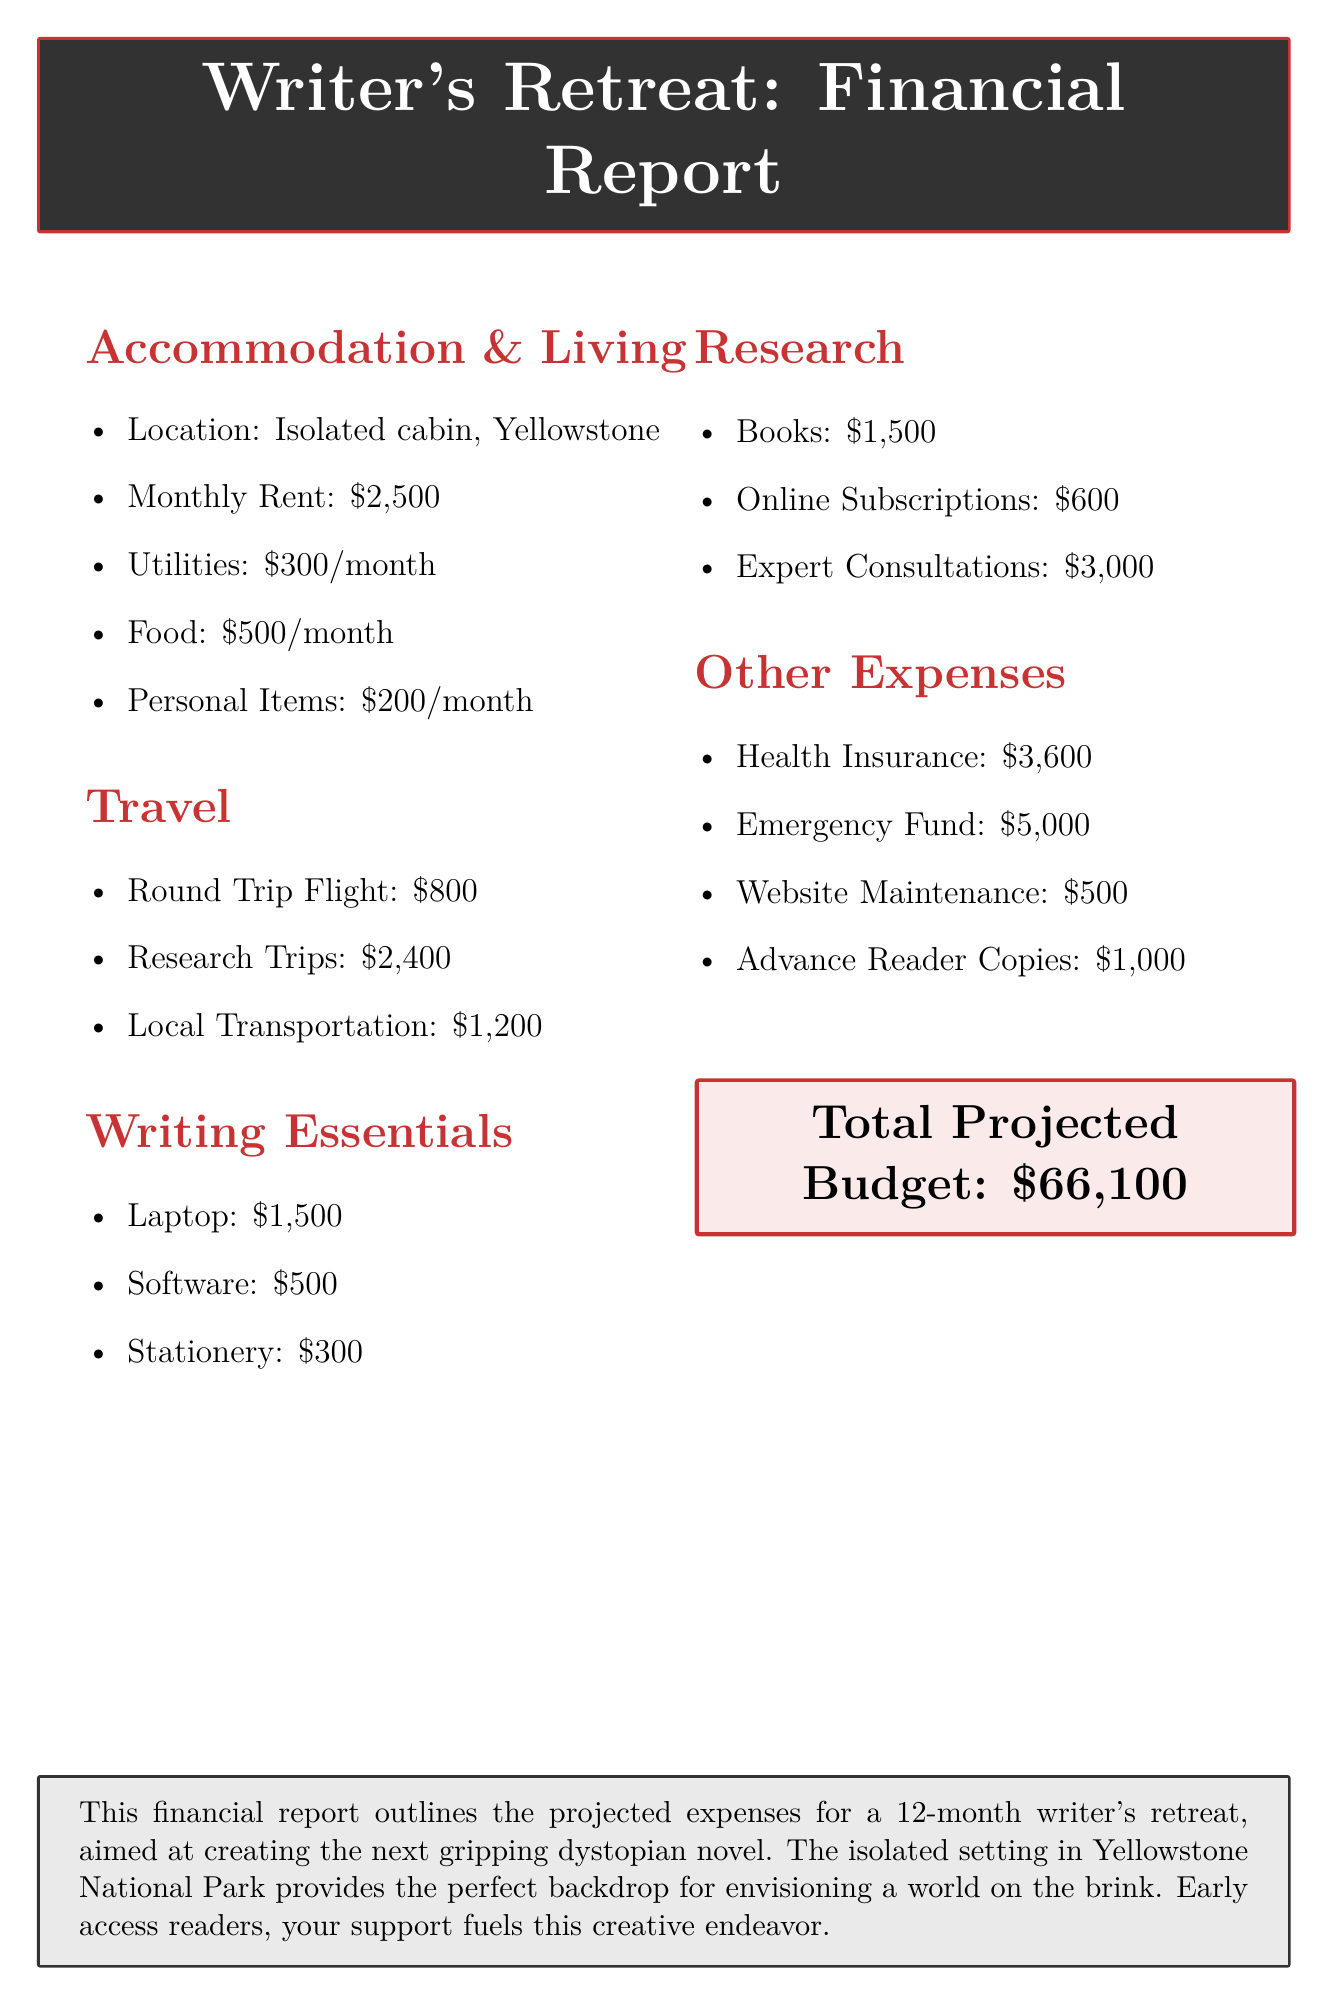What is the monthly rent for accommodation? The monthly rent for accommodation is listed under accommodation costs in the document.
Answer: $2500 How much is allocated for health insurance? Health insurance is a listed item in the document under other expenses, indicating its specific cost.
Answer: $3600 What is the total projected budget? The total projected budget is explicitly stated in a highlighted box toward the end of the report.
Answer: $66,100 How much is budgeted for research trips? The budget for research trips is specified in the travel expenses section of the document.
Answer: $2400 What is the location of the writer's retreat? The retreat's location is mentioned in the accommodation section, indicating where the retreat will take place.
Answer: Isolated cabin in Yellowstone National Park How much is the allocated budget for expert consultations? The budget for expert consultations is provided in the research costs section of the document.
Answer: $3000 What are the monthly expenses for food? Monthly food expenses are detailed in the accommodation and living section, which outlines essential costs.
Answer: $6000 What is included in the marketing budget? The marketing budget is outlined in the other expenses section, specifying its components discussed in the document.
Answer: Website Maintenance and Hosting, Advance Reader Copies How many months will the writer's retreat last? The duration of the retreat is stated at the beginning of the document, indicating how long the retreat will occur.
Answer: 12 months 